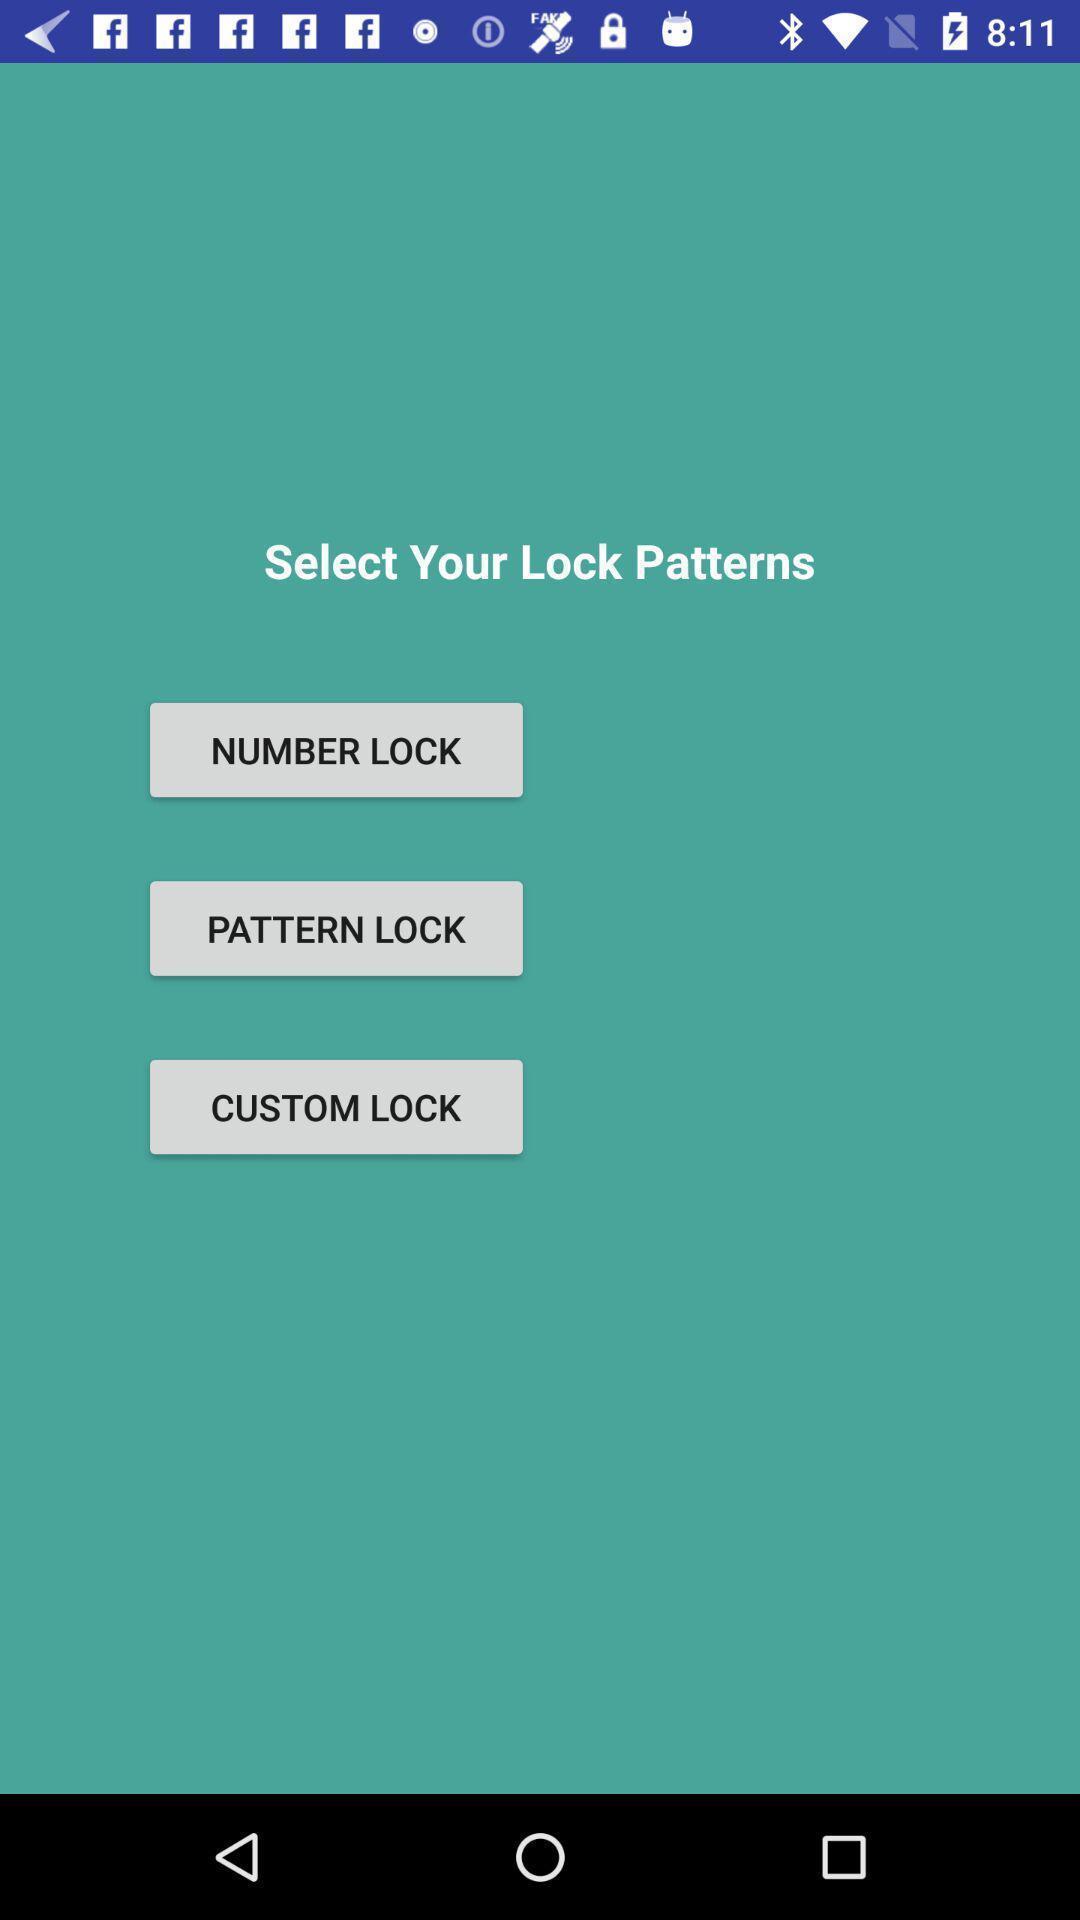Summarize the information in this screenshot. Screen displaying multiple lock options. 